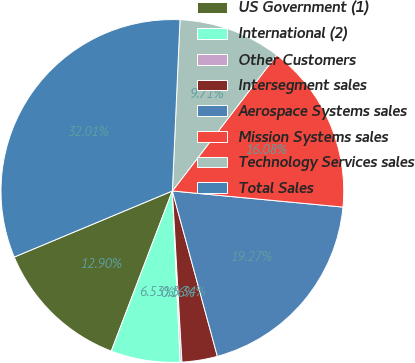<chart> <loc_0><loc_0><loc_500><loc_500><pie_chart><fcel>US Government (1)<fcel>International (2)<fcel>Other Customers<fcel>Intersegment sales<fcel>Aerospace Systems sales<fcel>Mission Systems sales<fcel>Technology Services sales<fcel>Total Sales<nl><fcel>12.9%<fcel>6.53%<fcel>0.16%<fcel>3.34%<fcel>19.27%<fcel>16.08%<fcel>9.71%<fcel>32.01%<nl></chart> 